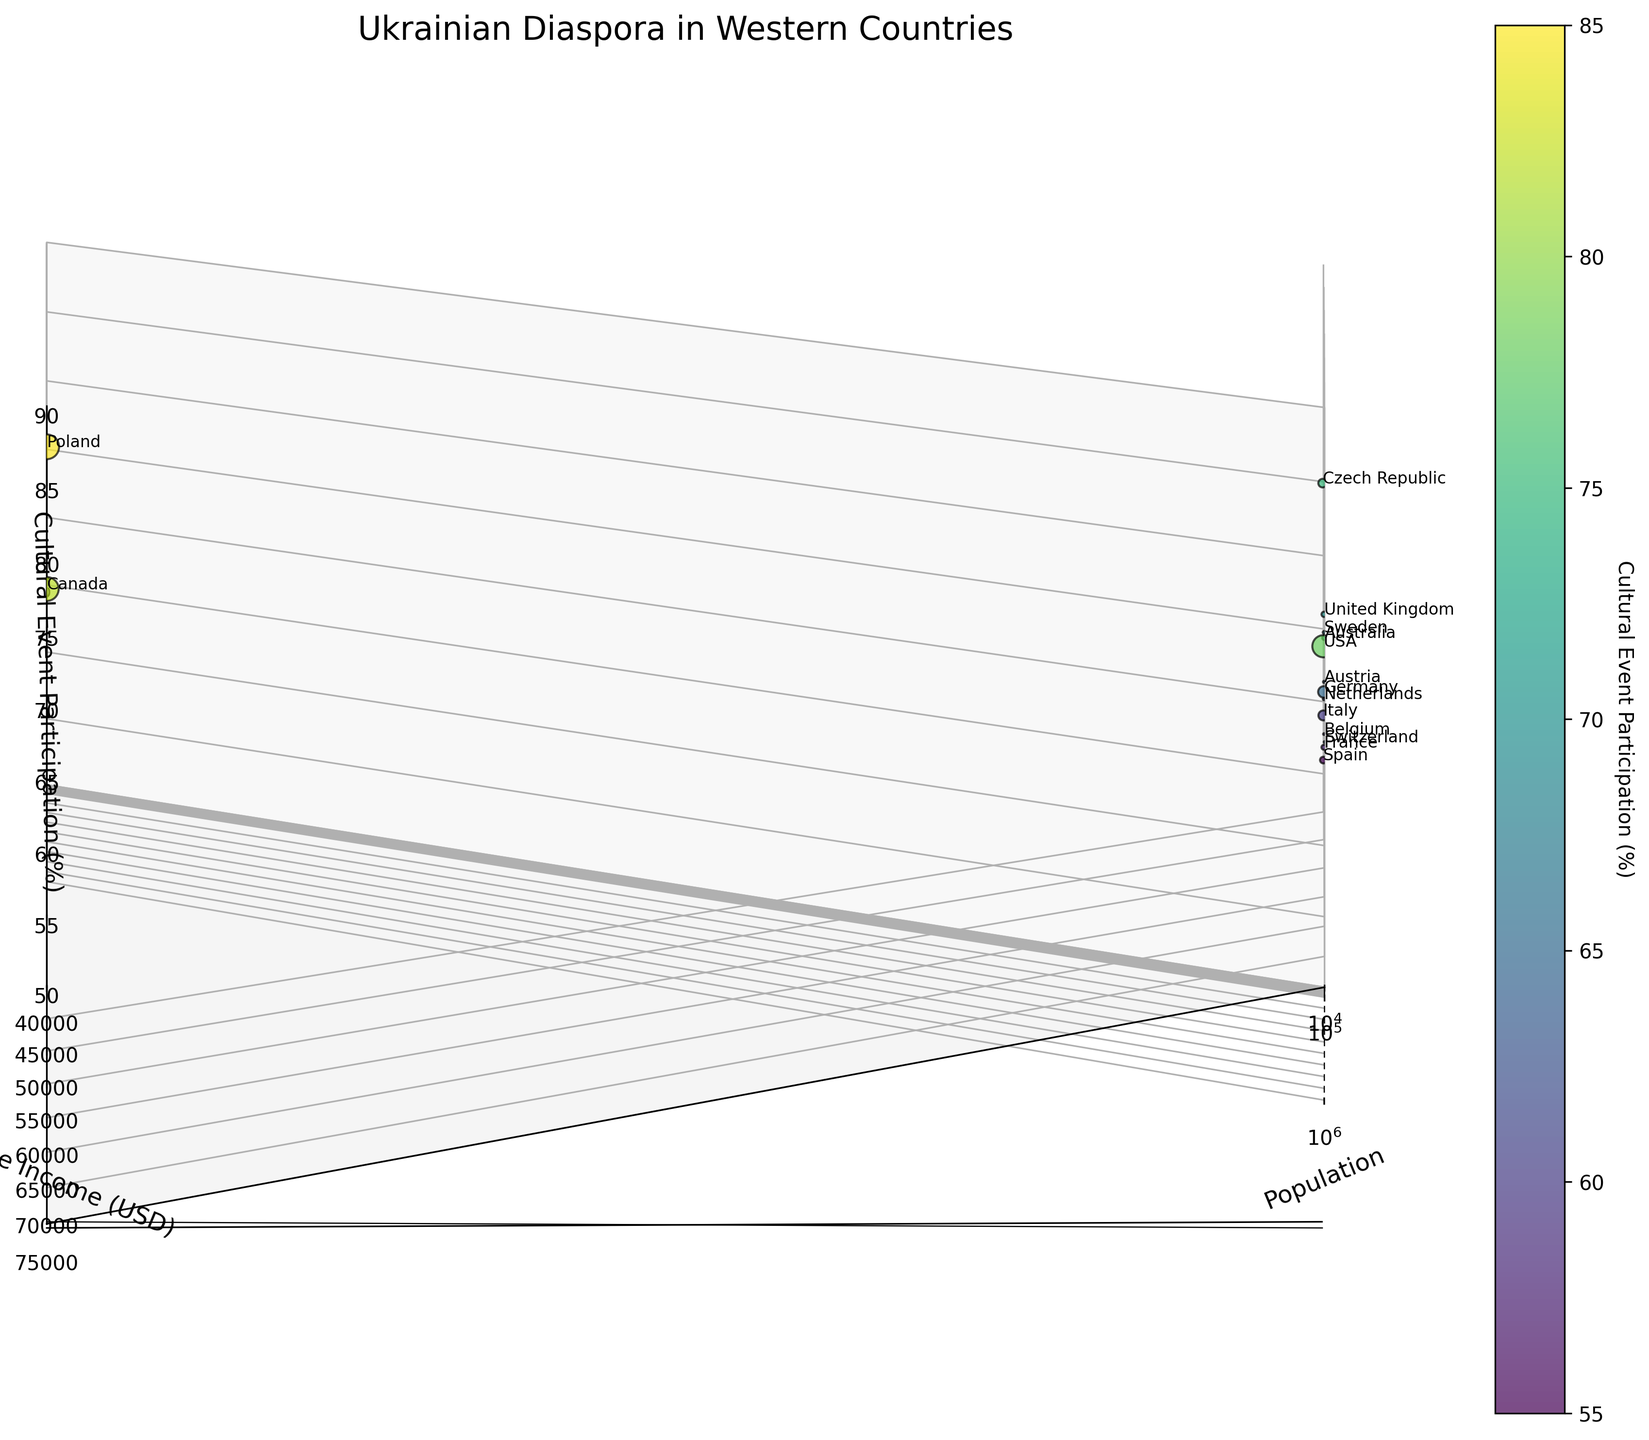What is the title of the figure? The title is usually found at the top of the figure. Looking at the figure, you can clearly see the title.
Answer: Ukrainian Diaspora in Western Countries What is the range of the x-axis? The x-axis is labeled 'Population'. From the lower and upper bounds of the axis, we can see that it ranges from 10,000 to 2,000,000.
Answer: 10,000 to 2,000,000 Which country has the highest average income? The y-axis is labeled 'Average Income (USD)', and the country with the highest point along this axis has the highest average income. Switzerland is at the top.
Answer: Switzerland How many countries are included in the plot? Each point in the scatter plot represents a country. By counting the number of points or countries labeled, you can determine this number.
Answer: 15 Which countries have cultural event participation higher than 80%? The z-axis is labeled 'Cultural Event Participation (%)'. By looking at data points higher than the 80% mark on the axis, Canada and Poland can be identified.
Answer: Canada and Poland What is the color range representing in the plot? The color bar indicates that colors represent the 'Cultural Event Participation (%)'. Observing the gradient, the start and end colors mark this range.
Answer: Cultural Event Participation (%) What is the average population of the countries listed? To find the average population, sum all populations and divide by the number of countries. This involves summing populations and dividing by 15. Calculation: (1200000 + 1400000 + 320000 + 70000 + 1500000 + 240000 + 110000 + 60000 + 50000 + 20000 + 15000 + 180000 + 12000 + 8000 + 7000) / 15 = 4,945,000 / 15
Answer: 329,667 Which country has the lowest cultural event participation? The z-axis is labeled 'Cultural Event Participation (%)'. By identifying the lowest data point along this axis, Spain has the lowest participation.
Answer: Spain Do any countries have an income above 70,000 USD? By examining the y-axis labeled 'Average Income (USD)', Switzerland is identified as it is above the 70,000 USD mark.
Answer: Yes, Switzerland If the population sizes are doubled, what would be the new population for Germany? The current population of Germany is 320,000. Doubling this value would involve multiplication: 320,000 * 2 = 640,000.
Answer: 640,000 